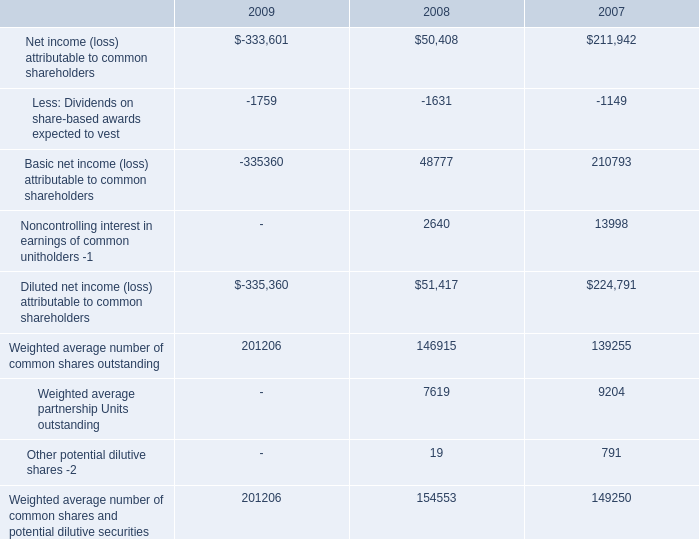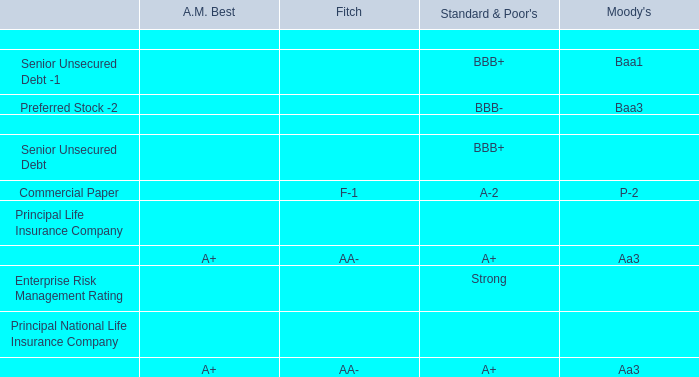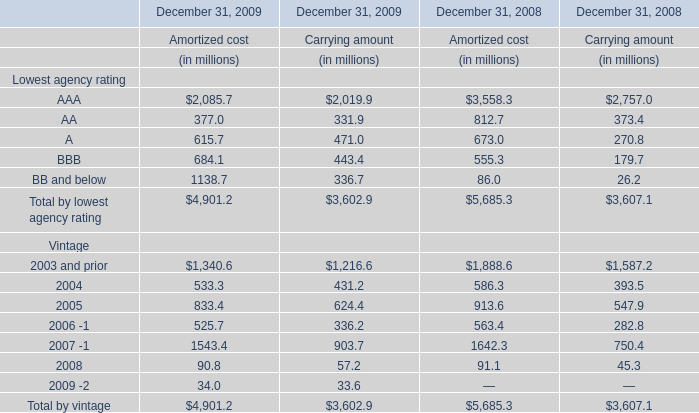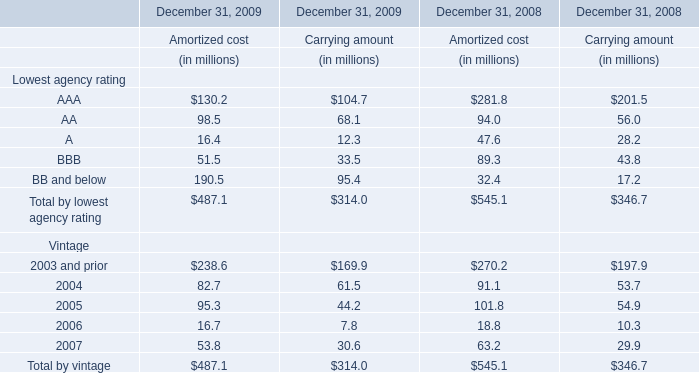What's the growth rate of AA for Carrying amount in 2009? 
Computations: ((68.1 - 56) / 56)
Answer: 0.21607. 